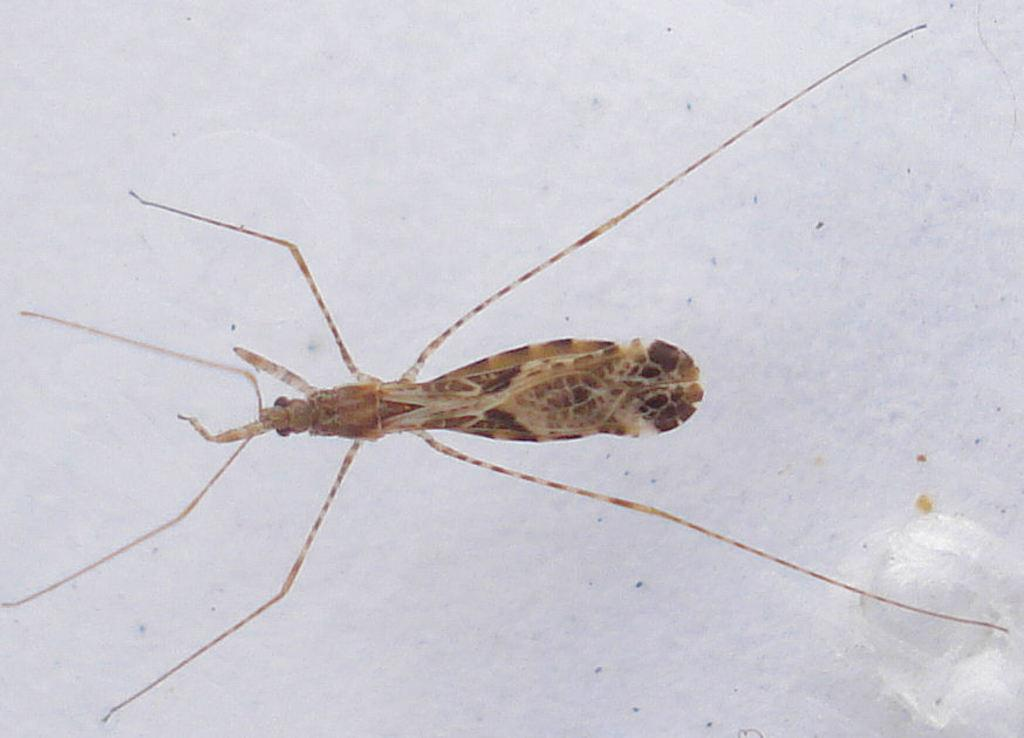What type of creature is present in the image? There is an insect in the image. What body parts does the insect have? The insect has legs and eyes. Where is the insect located in the image? The insect is on a white surface. What is the color of the background in the image? The background of the image is white. What type of pie is being served in the image? There is no pie present in the image; it features an insect on a white surface. What language is the insect speaking in the image? Insects do not speak any human language, and there is no indication of communication in the image. 